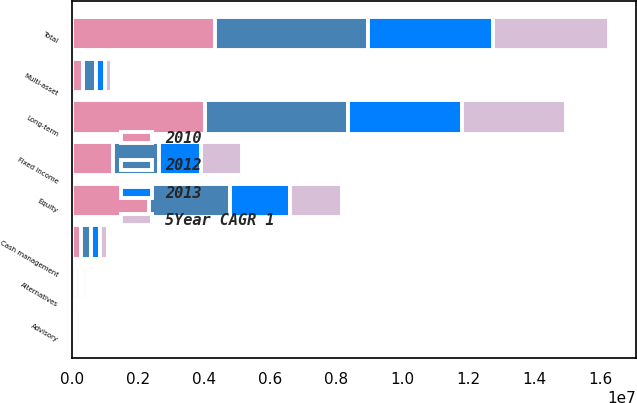<chart> <loc_0><loc_0><loc_500><loc_500><stacked_bar_chart><ecel><fcel>Equity<fcel>Fixed income<fcel>Multi-asset<fcel>Alternatives<fcel>Long-term<fcel>Cash management<fcel>Advisory<fcel>Total<nl><fcel>2012<fcel>2.45111e+06<fcel>1.39365e+06<fcel>377837<fcel>111240<fcel>4.33384e+06<fcel>296353<fcel>21701<fcel>4.6519e+06<nl><fcel>2010<fcel>2.3177e+06<fcel>1.24219e+06<fcel>341214<fcel>111114<fcel>4.01221e+06<fcel>275554<fcel>36325<fcel>4.32409e+06<nl><fcel>2013<fcel>1.8455e+06<fcel>1.25932e+06<fcel>267748<fcel>109795<fcel>3.48237e+06<fcel>263743<fcel>45479<fcel>3.79159e+06<nl><fcel>5Year CAGR 1<fcel>1.56011e+06<fcel>1.24772e+06<fcel>225170<fcel>104948<fcel>3.13795e+06<fcel>254665<fcel>120070<fcel>3.51268e+06<nl></chart> 